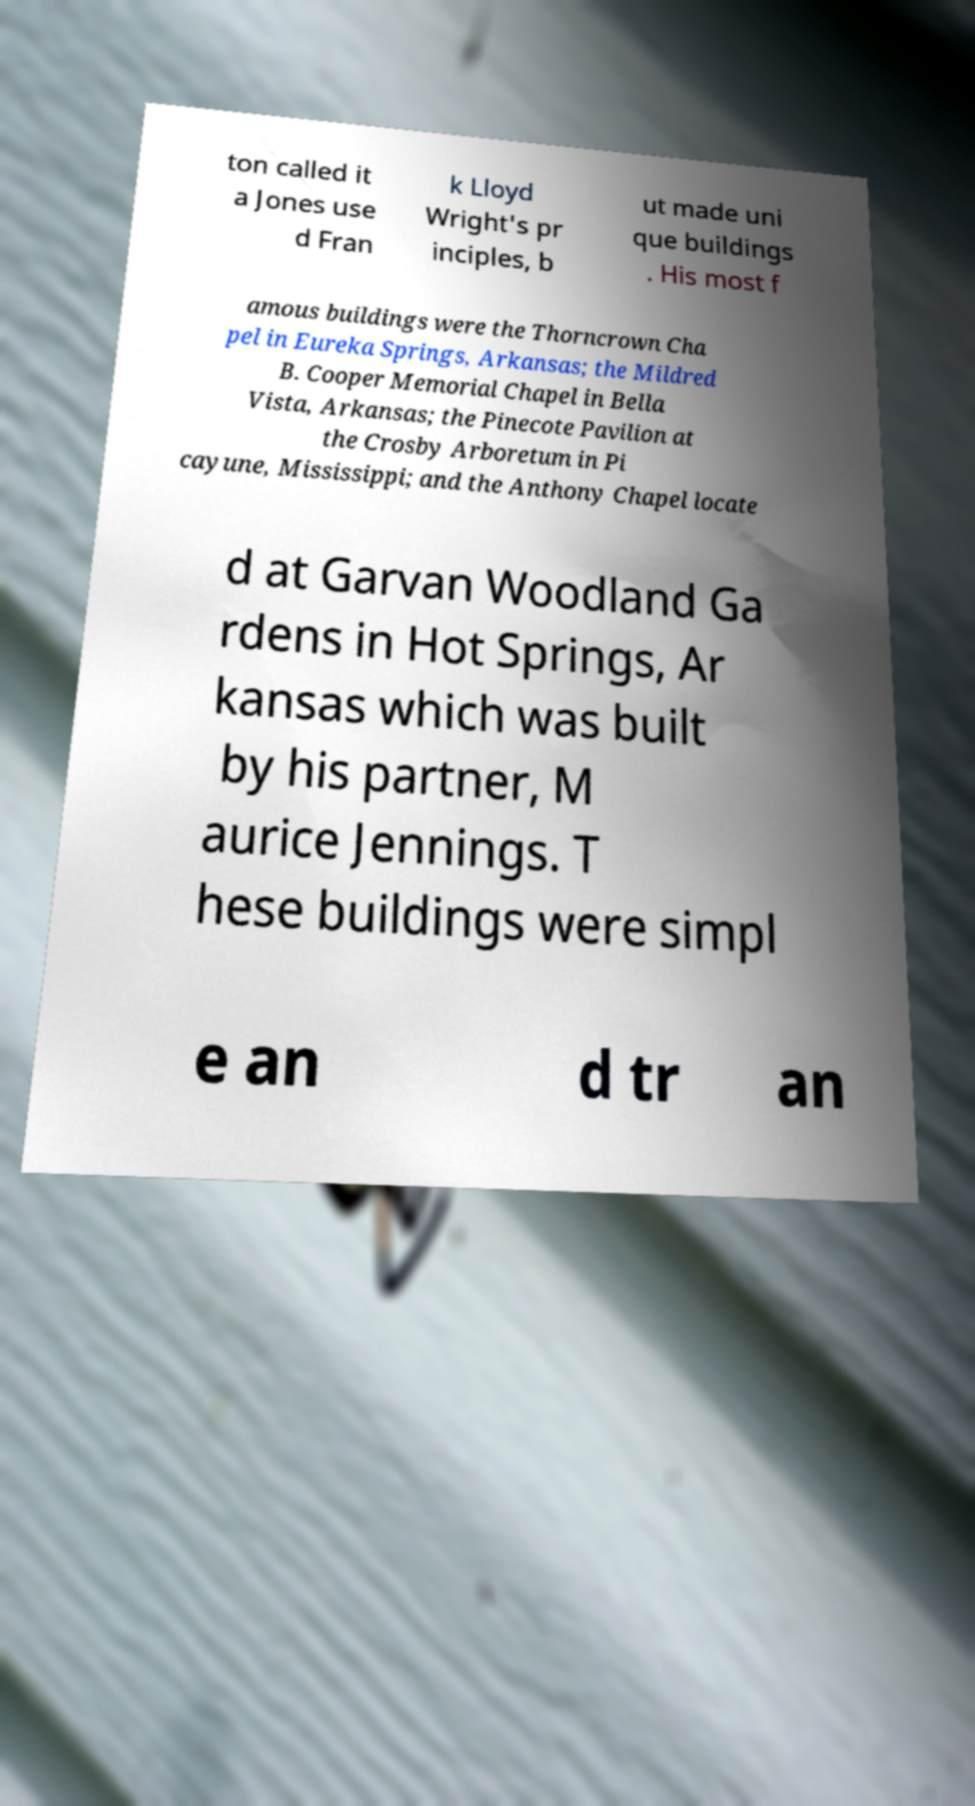Please identify and transcribe the text found in this image. ton called it a Jones use d Fran k Lloyd Wright's pr inciples, b ut made uni que buildings . His most f amous buildings were the Thorncrown Cha pel in Eureka Springs, Arkansas; the Mildred B. Cooper Memorial Chapel in Bella Vista, Arkansas; the Pinecote Pavilion at the Crosby Arboretum in Pi cayune, Mississippi; and the Anthony Chapel locate d at Garvan Woodland Ga rdens in Hot Springs, Ar kansas which was built by his partner, M aurice Jennings. T hese buildings were simpl e an d tr an 